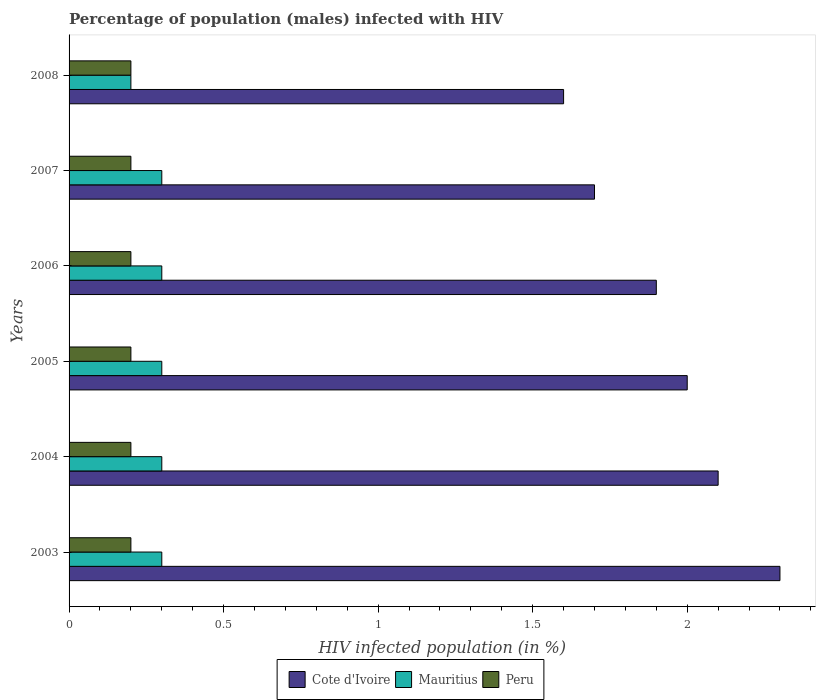Are the number of bars per tick equal to the number of legend labels?
Your response must be concise. Yes. Are the number of bars on each tick of the Y-axis equal?
Provide a short and direct response. Yes. How many bars are there on the 5th tick from the top?
Offer a very short reply. 3. Across all years, what is the maximum percentage of HIV infected male population in Peru?
Provide a short and direct response. 0.2. Across all years, what is the minimum percentage of HIV infected male population in Cote d'Ivoire?
Offer a very short reply. 1.6. In which year was the percentage of HIV infected male population in Peru maximum?
Your answer should be compact. 2003. In which year was the percentage of HIV infected male population in Mauritius minimum?
Offer a terse response. 2008. What is the total percentage of HIV infected male population in Mauritius in the graph?
Give a very brief answer. 1.7. What is the difference between the percentage of HIV infected male population in Mauritius in 2006 and that in 2008?
Provide a succinct answer. 0.1. What is the difference between the percentage of HIV infected male population in Cote d'Ivoire in 2006 and the percentage of HIV infected male population in Mauritius in 2007?
Offer a very short reply. 1.6. What is the average percentage of HIV infected male population in Mauritius per year?
Your answer should be compact. 0.28. In how many years, is the percentage of HIV infected male population in Cote d'Ivoire greater than 2.3 %?
Keep it short and to the point. 0. What is the difference between the highest and the second highest percentage of HIV infected male population in Mauritius?
Ensure brevity in your answer.  0. What is the difference between the highest and the lowest percentage of HIV infected male population in Cote d'Ivoire?
Ensure brevity in your answer.  0.7. What does the 2nd bar from the bottom in 2008 represents?
Your response must be concise. Mauritius. Is it the case that in every year, the sum of the percentage of HIV infected male population in Cote d'Ivoire and percentage of HIV infected male population in Mauritius is greater than the percentage of HIV infected male population in Peru?
Make the answer very short. Yes. What is the difference between two consecutive major ticks on the X-axis?
Offer a terse response. 0.5. Are the values on the major ticks of X-axis written in scientific E-notation?
Keep it short and to the point. No. Does the graph contain any zero values?
Your response must be concise. No. Where does the legend appear in the graph?
Provide a short and direct response. Bottom center. How are the legend labels stacked?
Your response must be concise. Horizontal. What is the title of the graph?
Give a very brief answer. Percentage of population (males) infected with HIV. What is the label or title of the X-axis?
Make the answer very short. HIV infected population (in %). What is the HIV infected population (in %) in Cote d'Ivoire in 2004?
Your answer should be very brief. 2.1. What is the HIV infected population (in %) of Mauritius in 2004?
Your answer should be compact. 0.3. What is the HIV infected population (in %) in Peru in 2004?
Provide a short and direct response. 0.2. What is the HIV infected population (in %) in Mauritius in 2005?
Your answer should be compact. 0.3. What is the HIV infected population (in %) of Cote d'Ivoire in 2006?
Offer a very short reply. 1.9. What is the HIV infected population (in %) in Peru in 2006?
Give a very brief answer. 0.2. What is the HIV infected population (in %) of Mauritius in 2007?
Give a very brief answer. 0.3. What is the HIV infected population (in %) of Peru in 2007?
Provide a short and direct response. 0.2. Across all years, what is the maximum HIV infected population (in %) of Cote d'Ivoire?
Give a very brief answer. 2.3. Across all years, what is the maximum HIV infected population (in %) in Peru?
Provide a short and direct response. 0.2. Across all years, what is the minimum HIV infected population (in %) in Mauritius?
Offer a terse response. 0.2. Across all years, what is the minimum HIV infected population (in %) of Peru?
Provide a short and direct response. 0.2. What is the total HIV infected population (in %) in Mauritius in the graph?
Your response must be concise. 1.7. What is the difference between the HIV infected population (in %) in Mauritius in 2003 and that in 2005?
Your answer should be very brief. 0. What is the difference between the HIV infected population (in %) of Mauritius in 2003 and that in 2007?
Offer a very short reply. 0. What is the difference between the HIV infected population (in %) in Cote d'Ivoire in 2003 and that in 2008?
Make the answer very short. 0.7. What is the difference between the HIV infected population (in %) of Mauritius in 2003 and that in 2008?
Your response must be concise. 0.1. What is the difference between the HIV infected population (in %) of Peru in 2003 and that in 2008?
Offer a very short reply. 0. What is the difference between the HIV infected population (in %) of Peru in 2004 and that in 2006?
Offer a very short reply. 0. What is the difference between the HIV infected population (in %) in Peru in 2004 and that in 2007?
Your answer should be compact. 0. What is the difference between the HIV infected population (in %) in Cote d'Ivoire in 2005 and that in 2006?
Keep it short and to the point. 0.1. What is the difference between the HIV infected population (in %) of Mauritius in 2005 and that in 2006?
Keep it short and to the point. 0. What is the difference between the HIV infected population (in %) of Cote d'Ivoire in 2005 and that in 2007?
Provide a short and direct response. 0.3. What is the difference between the HIV infected population (in %) in Mauritius in 2005 and that in 2007?
Offer a terse response. 0. What is the difference between the HIV infected population (in %) in Cote d'Ivoire in 2005 and that in 2008?
Provide a short and direct response. 0.4. What is the difference between the HIV infected population (in %) in Mauritius in 2005 and that in 2008?
Your response must be concise. 0.1. What is the difference between the HIV infected population (in %) of Cote d'Ivoire in 2006 and that in 2007?
Give a very brief answer. 0.2. What is the difference between the HIV infected population (in %) in Mauritius in 2006 and that in 2007?
Ensure brevity in your answer.  0. What is the difference between the HIV infected population (in %) in Mauritius in 2006 and that in 2008?
Make the answer very short. 0.1. What is the difference between the HIV infected population (in %) in Mauritius in 2007 and that in 2008?
Keep it short and to the point. 0.1. What is the difference between the HIV infected population (in %) of Cote d'Ivoire in 2003 and the HIV infected population (in %) of Mauritius in 2004?
Provide a succinct answer. 2. What is the difference between the HIV infected population (in %) in Cote d'Ivoire in 2003 and the HIV infected population (in %) in Peru in 2005?
Provide a short and direct response. 2.1. What is the difference between the HIV infected population (in %) of Mauritius in 2003 and the HIV infected population (in %) of Peru in 2005?
Keep it short and to the point. 0.1. What is the difference between the HIV infected population (in %) in Mauritius in 2003 and the HIV infected population (in %) in Peru in 2007?
Offer a very short reply. 0.1. What is the difference between the HIV infected population (in %) of Cote d'Ivoire in 2003 and the HIV infected population (in %) of Mauritius in 2008?
Provide a short and direct response. 2.1. What is the difference between the HIV infected population (in %) of Cote d'Ivoire in 2003 and the HIV infected population (in %) of Peru in 2008?
Give a very brief answer. 2.1. What is the difference between the HIV infected population (in %) of Cote d'Ivoire in 2004 and the HIV infected population (in %) of Mauritius in 2005?
Your answer should be compact. 1.8. What is the difference between the HIV infected population (in %) in Cote d'Ivoire in 2004 and the HIV infected population (in %) in Peru in 2005?
Provide a short and direct response. 1.9. What is the difference between the HIV infected population (in %) in Mauritius in 2004 and the HIV infected population (in %) in Peru in 2005?
Ensure brevity in your answer.  0.1. What is the difference between the HIV infected population (in %) of Cote d'Ivoire in 2004 and the HIV infected population (in %) of Peru in 2006?
Offer a terse response. 1.9. What is the difference between the HIV infected population (in %) of Mauritius in 2004 and the HIV infected population (in %) of Peru in 2006?
Your response must be concise. 0.1. What is the difference between the HIV infected population (in %) in Cote d'Ivoire in 2004 and the HIV infected population (in %) in Mauritius in 2008?
Give a very brief answer. 1.9. What is the difference between the HIV infected population (in %) in Mauritius in 2004 and the HIV infected population (in %) in Peru in 2008?
Offer a terse response. 0.1. What is the difference between the HIV infected population (in %) in Mauritius in 2005 and the HIV infected population (in %) in Peru in 2006?
Offer a very short reply. 0.1. What is the difference between the HIV infected population (in %) in Cote d'Ivoire in 2005 and the HIV infected population (in %) in Mauritius in 2007?
Offer a terse response. 1.7. What is the difference between the HIV infected population (in %) of Mauritius in 2005 and the HIV infected population (in %) of Peru in 2007?
Keep it short and to the point. 0.1. What is the difference between the HIV infected population (in %) in Cote d'Ivoire in 2005 and the HIV infected population (in %) in Peru in 2008?
Your answer should be very brief. 1.8. What is the difference between the HIV infected population (in %) of Cote d'Ivoire in 2006 and the HIV infected population (in %) of Peru in 2008?
Your answer should be compact. 1.7. What is the difference between the HIV infected population (in %) in Mauritius in 2006 and the HIV infected population (in %) in Peru in 2008?
Provide a short and direct response. 0.1. What is the difference between the HIV infected population (in %) of Cote d'Ivoire in 2007 and the HIV infected population (in %) of Peru in 2008?
Your response must be concise. 1.5. What is the difference between the HIV infected population (in %) in Mauritius in 2007 and the HIV infected population (in %) in Peru in 2008?
Offer a very short reply. 0.1. What is the average HIV infected population (in %) of Cote d'Ivoire per year?
Provide a succinct answer. 1.93. What is the average HIV infected population (in %) in Mauritius per year?
Make the answer very short. 0.28. What is the average HIV infected population (in %) in Peru per year?
Ensure brevity in your answer.  0.2. In the year 2003, what is the difference between the HIV infected population (in %) of Cote d'Ivoire and HIV infected population (in %) of Mauritius?
Keep it short and to the point. 2. In the year 2003, what is the difference between the HIV infected population (in %) in Mauritius and HIV infected population (in %) in Peru?
Offer a very short reply. 0.1. In the year 2004, what is the difference between the HIV infected population (in %) in Cote d'Ivoire and HIV infected population (in %) in Mauritius?
Provide a succinct answer. 1.8. In the year 2004, what is the difference between the HIV infected population (in %) of Cote d'Ivoire and HIV infected population (in %) of Peru?
Provide a short and direct response. 1.9. In the year 2005, what is the difference between the HIV infected population (in %) of Mauritius and HIV infected population (in %) of Peru?
Your answer should be very brief. 0.1. In the year 2006, what is the difference between the HIV infected population (in %) of Cote d'Ivoire and HIV infected population (in %) of Mauritius?
Offer a very short reply. 1.6. In the year 2006, what is the difference between the HIV infected population (in %) of Mauritius and HIV infected population (in %) of Peru?
Keep it short and to the point. 0.1. In the year 2008, what is the difference between the HIV infected population (in %) in Cote d'Ivoire and HIV infected population (in %) in Mauritius?
Ensure brevity in your answer.  1.4. In the year 2008, what is the difference between the HIV infected population (in %) of Cote d'Ivoire and HIV infected population (in %) of Peru?
Your response must be concise. 1.4. What is the ratio of the HIV infected population (in %) in Cote d'Ivoire in 2003 to that in 2004?
Ensure brevity in your answer.  1.1. What is the ratio of the HIV infected population (in %) in Peru in 2003 to that in 2004?
Provide a succinct answer. 1. What is the ratio of the HIV infected population (in %) in Cote d'Ivoire in 2003 to that in 2005?
Offer a terse response. 1.15. What is the ratio of the HIV infected population (in %) of Cote d'Ivoire in 2003 to that in 2006?
Ensure brevity in your answer.  1.21. What is the ratio of the HIV infected population (in %) in Mauritius in 2003 to that in 2006?
Your answer should be compact. 1. What is the ratio of the HIV infected population (in %) of Cote d'Ivoire in 2003 to that in 2007?
Give a very brief answer. 1.35. What is the ratio of the HIV infected population (in %) in Peru in 2003 to that in 2007?
Make the answer very short. 1. What is the ratio of the HIV infected population (in %) of Cote d'Ivoire in 2003 to that in 2008?
Your answer should be very brief. 1.44. What is the ratio of the HIV infected population (in %) in Peru in 2003 to that in 2008?
Offer a terse response. 1. What is the ratio of the HIV infected population (in %) of Mauritius in 2004 to that in 2005?
Provide a short and direct response. 1. What is the ratio of the HIV infected population (in %) in Cote d'Ivoire in 2004 to that in 2006?
Provide a succinct answer. 1.11. What is the ratio of the HIV infected population (in %) in Peru in 2004 to that in 2006?
Your response must be concise. 1. What is the ratio of the HIV infected population (in %) of Cote d'Ivoire in 2004 to that in 2007?
Give a very brief answer. 1.24. What is the ratio of the HIV infected population (in %) of Cote d'Ivoire in 2004 to that in 2008?
Make the answer very short. 1.31. What is the ratio of the HIV infected population (in %) in Mauritius in 2004 to that in 2008?
Your answer should be compact. 1.5. What is the ratio of the HIV infected population (in %) in Cote d'Ivoire in 2005 to that in 2006?
Ensure brevity in your answer.  1.05. What is the ratio of the HIV infected population (in %) of Peru in 2005 to that in 2006?
Your answer should be very brief. 1. What is the ratio of the HIV infected population (in %) of Cote d'Ivoire in 2005 to that in 2007?
Make the answer very short. 1.18. What is the ratio of the HIV infected population (in %) in Mauritius in 2005 to that in 2007?
Offer a very short reply. 1. What is the ratio of the HIV infected population (in %) of Peru in 2005 to that in 2007?
Offer a terse response. 1. What is the ratio of the HIV infected population (in %) of Mauritius in 2005 to that in 2008?
Ensure brevity in your answer.  1.5. What is the ratio of the HIV infected population (in %) of Peru in 2005 to that in 2008?
Give a very brief answer. 1. What is the ratio of the HIV infected population (in %) in Cote d'Ivoire in 2006 to that in 2007?
Your response must be concise. 1.12. What is the ratio of the HIV infected population (in %) of Cote d'Ivoire in 2006 to that in 2008?
Give a very brief answer. 1.19. What is the ratio of the HIV infected population (in %) of Peru in 2006 to that in 2008?
Make the answer very short. 1. What is the ratio of the HIV infected population (in %) in Mauritius in 2007 to that in 2008?
Give a very brief answer. 1.5. What is the difference between the highest and the second highest HIV infected population (in %) in Mauritius?
Offer a very short reply. 0. What is the difference between the highest and the lowest HIV infected population (in %) in Mauritius?
Ensure brevity in your answer.  0.1. 